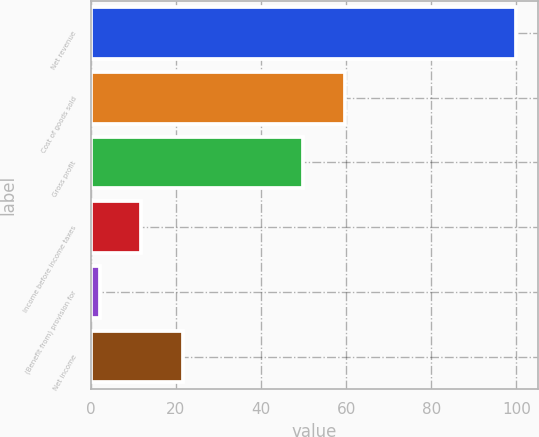<chart> <loc_0><loc_0><loc_500><loc_500><bar_chart><fcel>Net revenue<fcel>Cost of goods sold<fcel>Gross profit<fcel>Income before income taxes<fcel>(Benefit from) provision for<fcel>Net income<nl><fcel>100<fcel>59.69<fcel>49.9<fcel>11.89<fcel>2.1<fcel>21.68<nl></chart> 